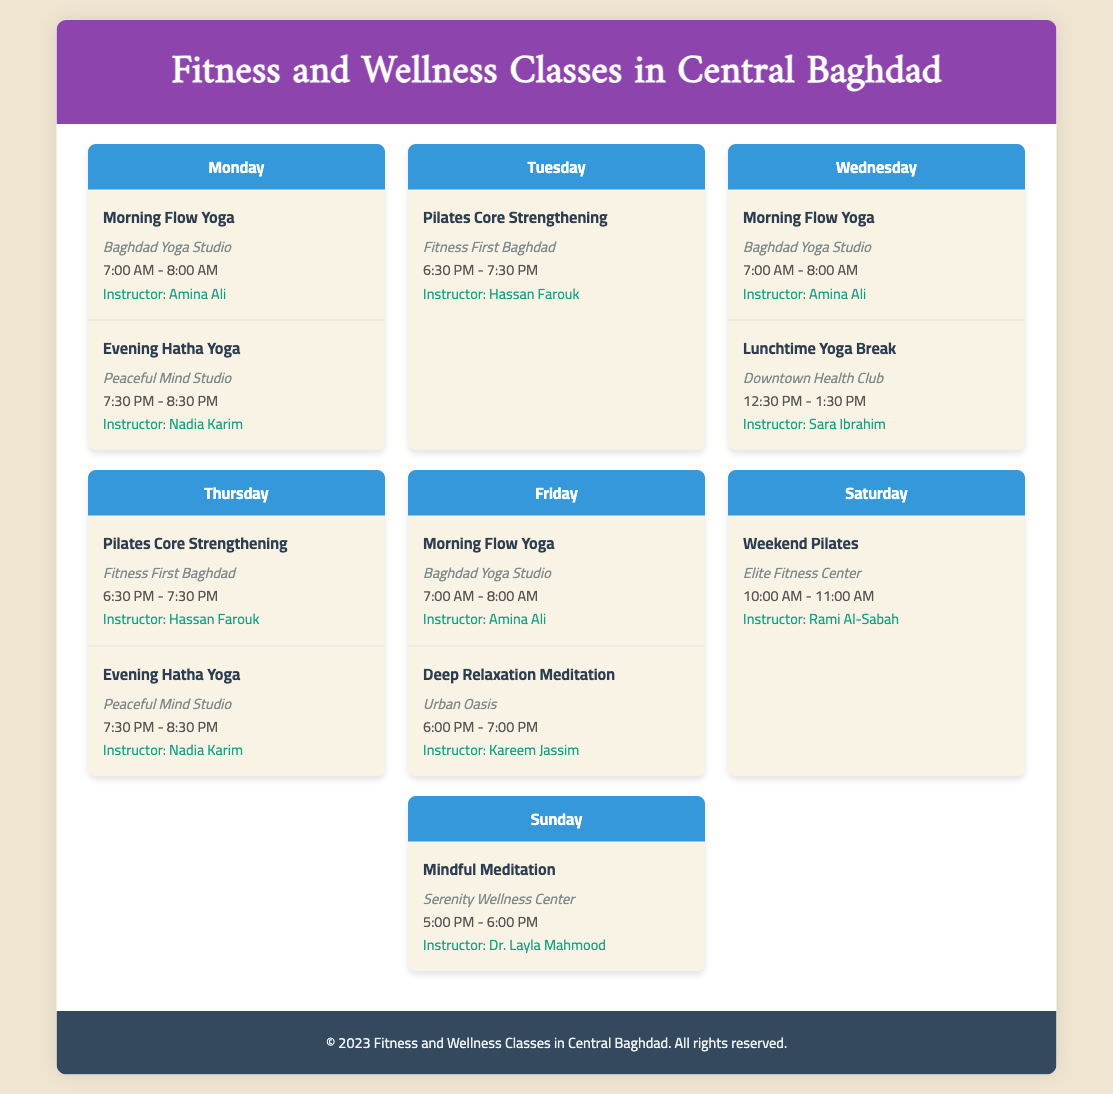What time does the Morning Flow Yoga class start? The Morning Flow Yoga class begins at 7:00 AM on Mondays, Wednesdays, and Fridays.
Answer: 7:00 AM Who is the instructor for the Evening Hatha Yoga class? The Evening Hatha Yoga class is taught by Nadia Karim.
Answer: Nadia Karim Where is the Pilates Core Strengthening class held? The Pilates Core Strengthening class is held at Fitness First Baghdad on Tuesdays and Thursdays.
Answer: Fitness First Baghdad On which day does the Mindful Meditation class take place? The Mindful Meditation class is scheduled for Sunday.
Answer: Sunday How long is the Deep Relaxation Meditation class? The Deep Relaxation Meditation class lasts for one hour, from 6:00 PM to 7:00 PM.
Answer: One hour What class is offered at Serenity Wellness Center? The class held at Serenity Wellness Center is Mindful Meditation.
Answer: Mindful Meditation Which instructor teaches yoga classes on Monday? Amina Ali teaches the Morning Flow Yoga class on Monday.
Answer: Amina Ali What is the venue for the Weekend Pilates class? The Weekend Pilates class takes place at Elite Fitness Center.
Answer: Elite Fitness Center How many yoga classes are offered during the week? There are five yoga classes (Morning Flow Yoga, Evening Hatha Yoga, and Lunchtime Yoga Break) offered during the week.
Answer: Five classes 